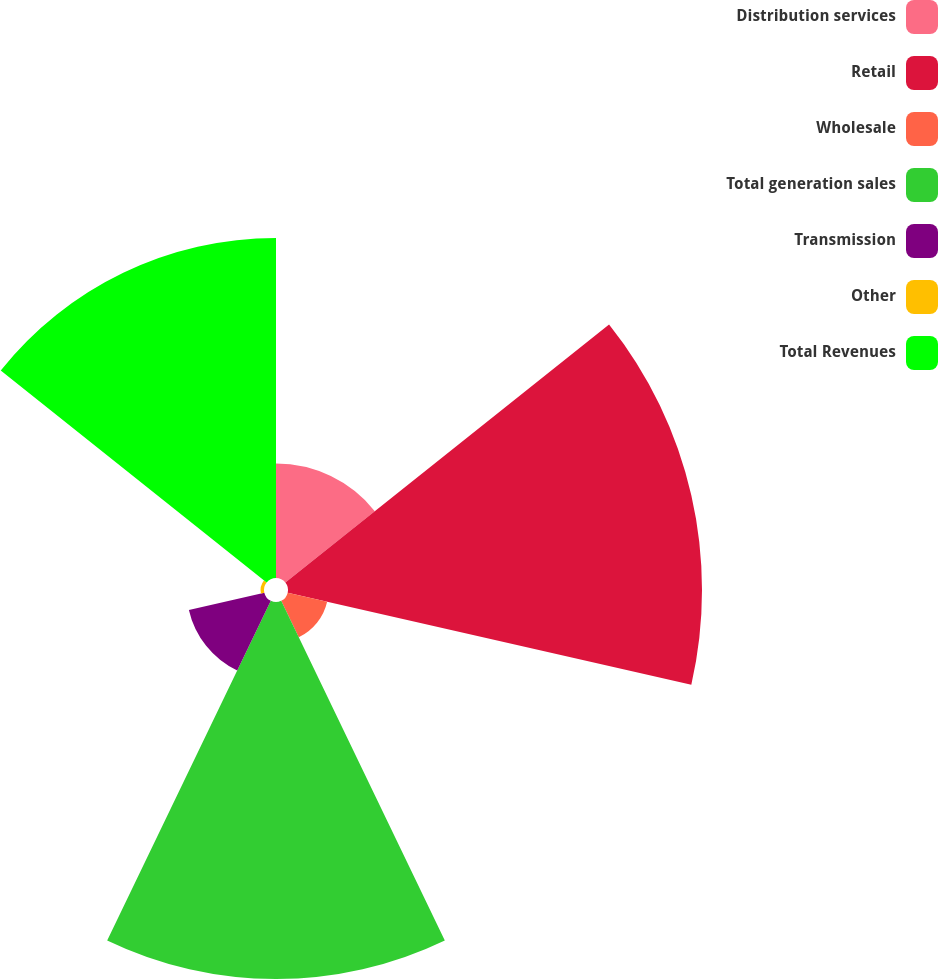Convert chart. <chart><loc_0><loc_0><loc_500><loc_500><pie_chart><fcel>Distribution services<fcel>Retail<fcel>Wholesale<fcel>Total generation sales<fcel>Transmission<fcel>Other<fcel>Total Revenues<nl><fcel>8.37%<fcel>30.29%<fcel>2.96%<fcel>27.59%<fcel>5.66%<fcel>0.25%<fcel>24.88%<nl></chart> 